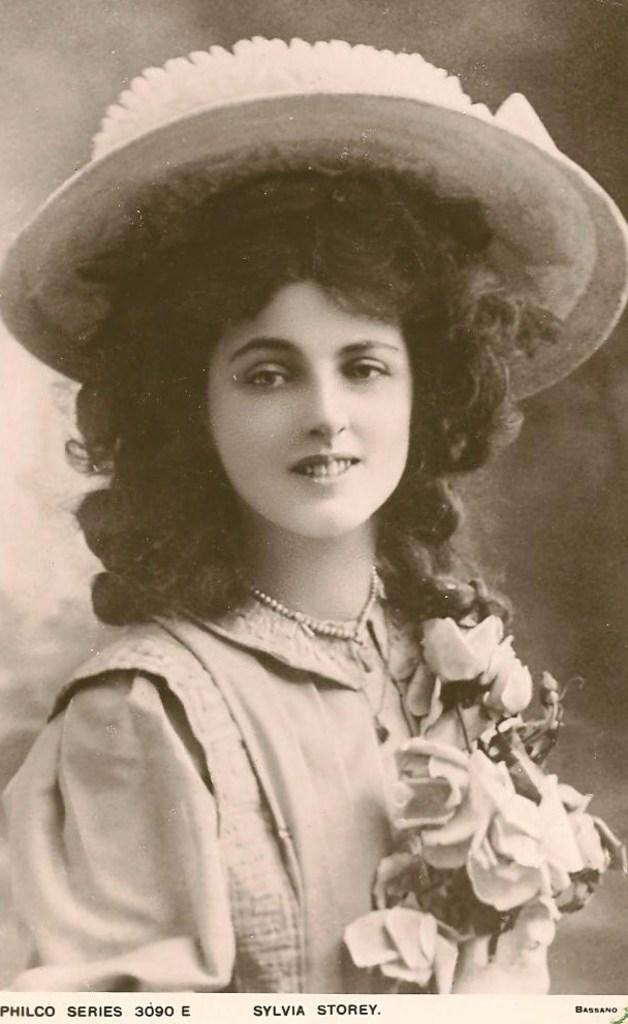Who is present in the image? There is a woman in the image. What is the woman wearing on her head? The woman is wearing a hat. What type of coil can be seen in the image? There is no coil present in the image. How many clouds are visible in the image? There is no information about clouds in the image, as it only features a woman wearing a hat. 